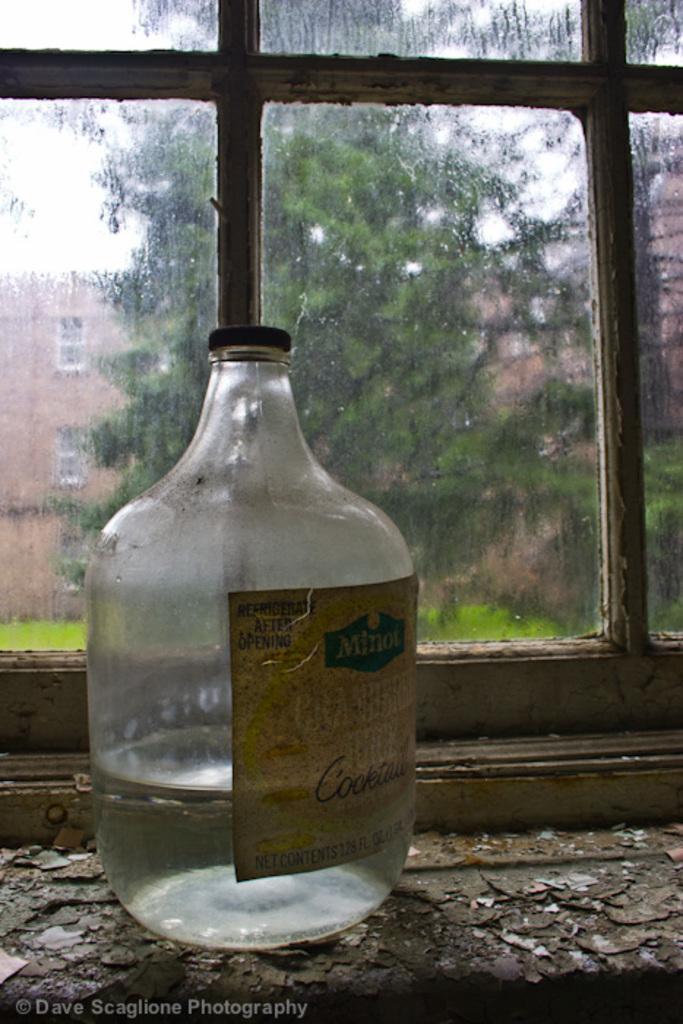Could you give a brief overview of what you see in this image? there is a glass bottle. behind that there is a window. outside the window there are trees and buildings 